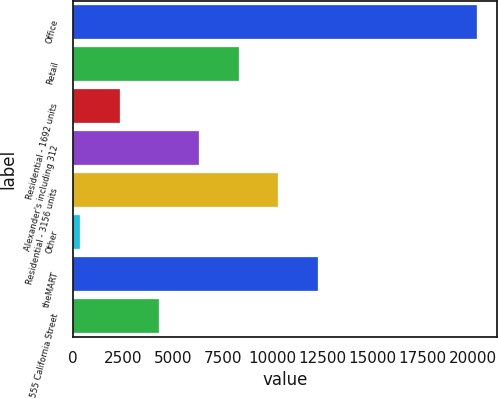Convert chart. <chart><loc_0><loc_0><loc_500><loc_500><bar_chart><fcel>Office<fcel>Retail<fcel>Residential - 1692 units<fcel>Alexander's including 312<fcel>Residential - 3156 units<fcel>Other<fcel>theMART<fcel>555 California Street<nl><fcel>20227<fcel>8288.8<fcel>2319.7<fcel>6299.1<fcel>10278.5<fcel>330<fcel>12268.2<fcel>4309.4<nl></chart> 